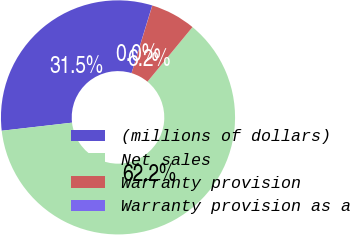<chart> <loc_0><loc_0><loc_500><loc_500><pie_chart><fcel>(millions of dollars)<fcel>Net sales<fcel>Warranty provision<fcel>Warranty provision as a<nl><fcel>31.54%<fcel>62.2%<fcel>6.24%<fcel>0.02%<nl></chart> 